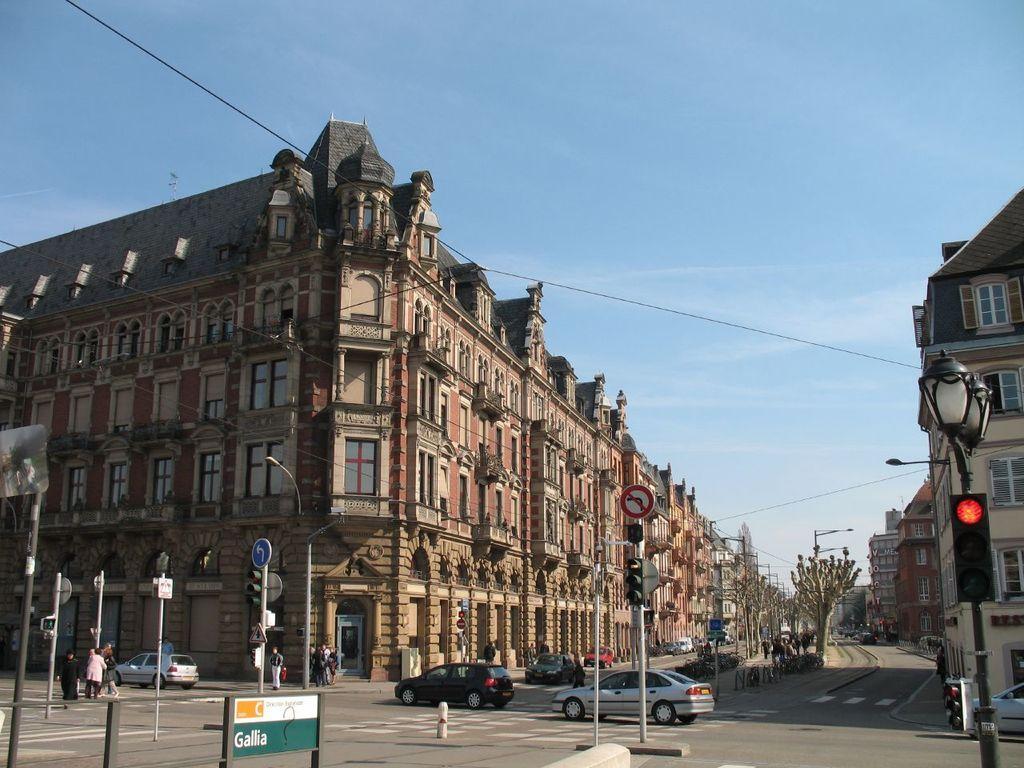In one or two sentences, can you explain what this image depicts? In the image I can see there are few people, cars and electrical poles on the road, beside the road there are some buildings. 